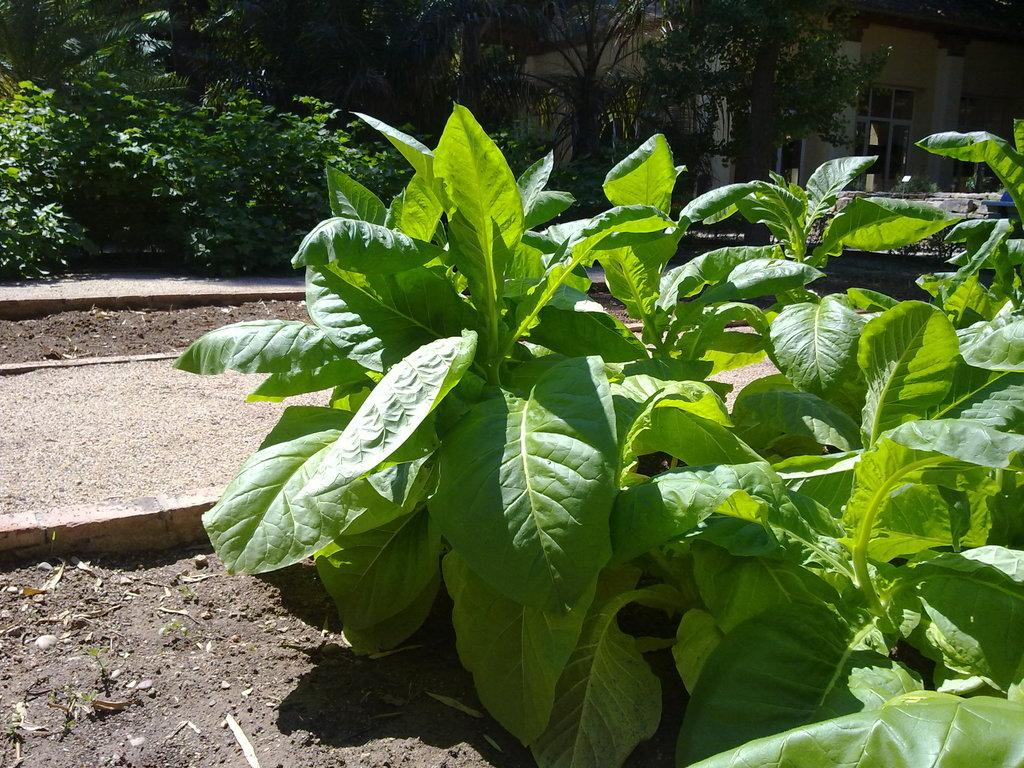What can be seen in the foreground of the picture? In the foreground of the picture, there are plants, soil, and stones. What is located on the left side of the picture? On the left side of the picture, there is pavement and soil. What is visible in the background of the picture? In the background of the picture, there are plants, trees, a door, and a building. Can you see any lizards fighting in the basin in the image? There are no lizards or basins present in the image. What type of fight is happening in the background of the picture? There is no fight depicted in the image; it features plants, trees, a door, and a building in the background. 